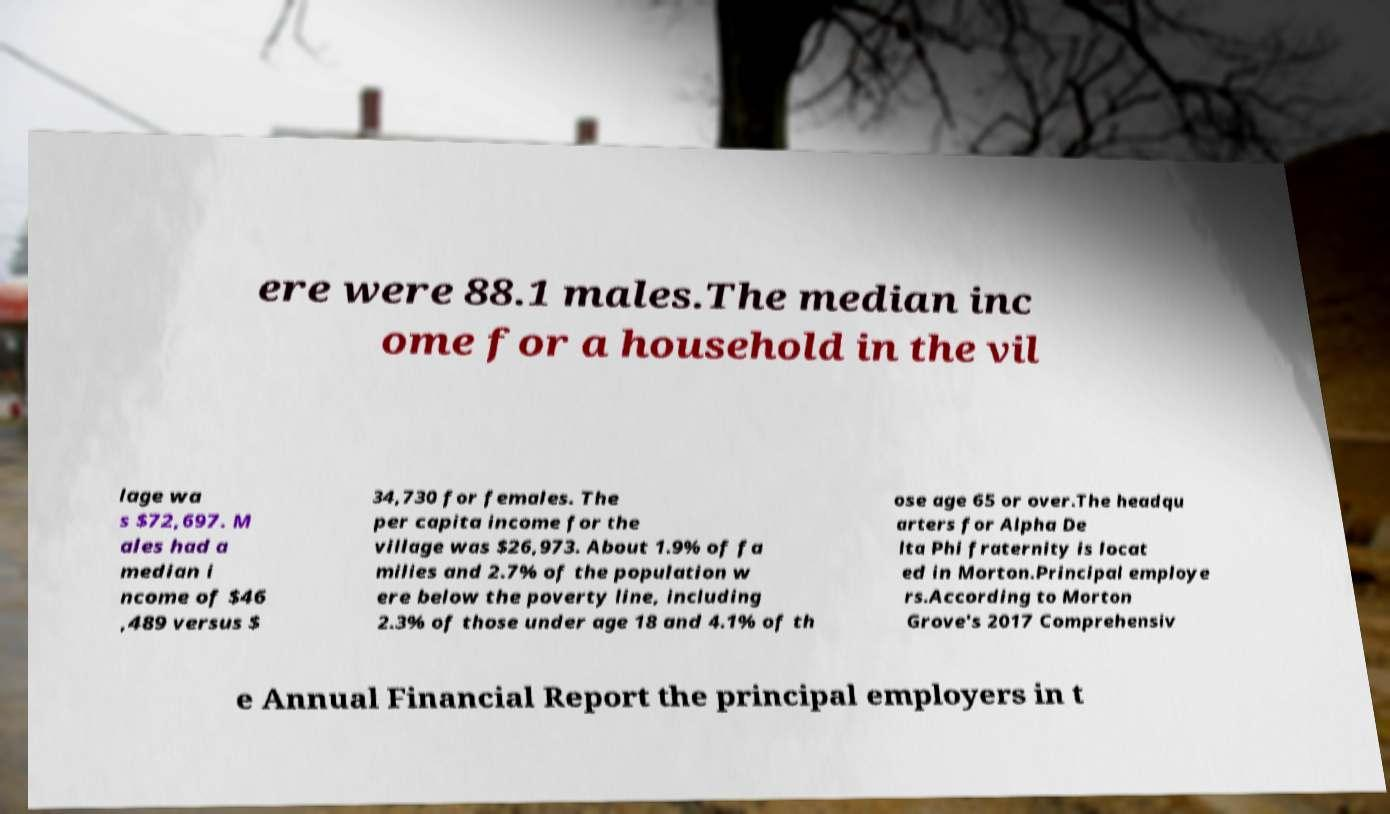Can you accurately transcribe the text from the provided image for me? ere were 88.1 males.The median inc ome for a household in the vil lage wa s $72,697. M ales had a median i ncome of $46 ,489 versus $ 34,730 for females. The per capita income for the village was $26,973. About 1.9% of fa milies and 2.7% of the population w ere below the poverty line, including 2.3% of those under age 18 and 4.1% of th ose age 65 or over.The headqu arters for Alpha De lta Phi fraternity is locat ed in Morton.Principal employe rs.According to Morton Grove's 2017 Comprehensiv e Annual Financial Report the principal employers in t 